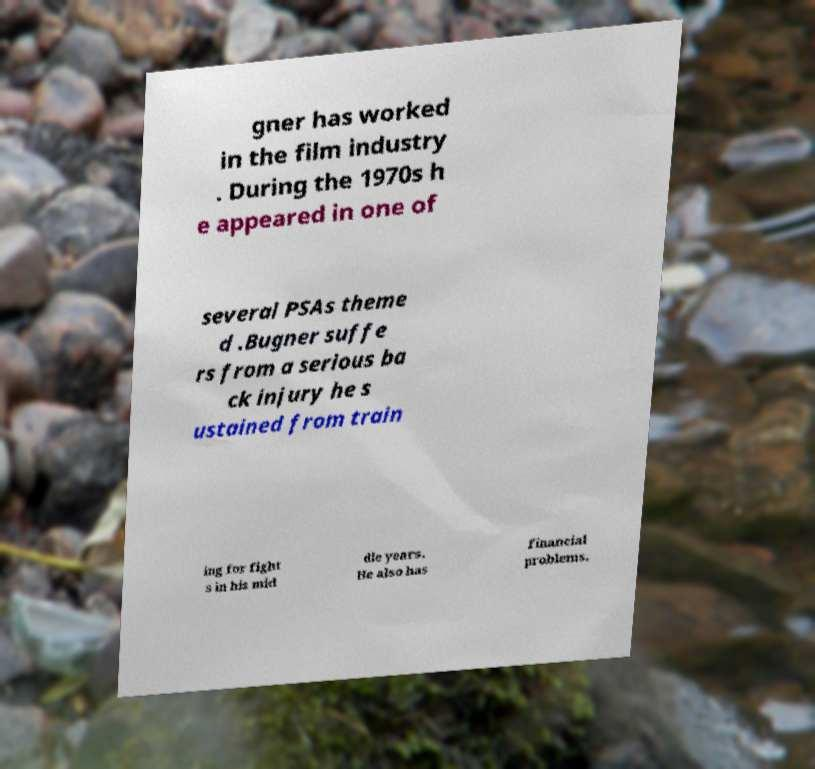Please read and relay the text visible in this image. What does it say? gner has worked in the film industry . During the 1970s h e appeared in one of several PSAs theme d .Bugner suffe rs from a serious ba ck injury he s ustained from train ing for fight s in his mid dle years. He also has financial problems. 